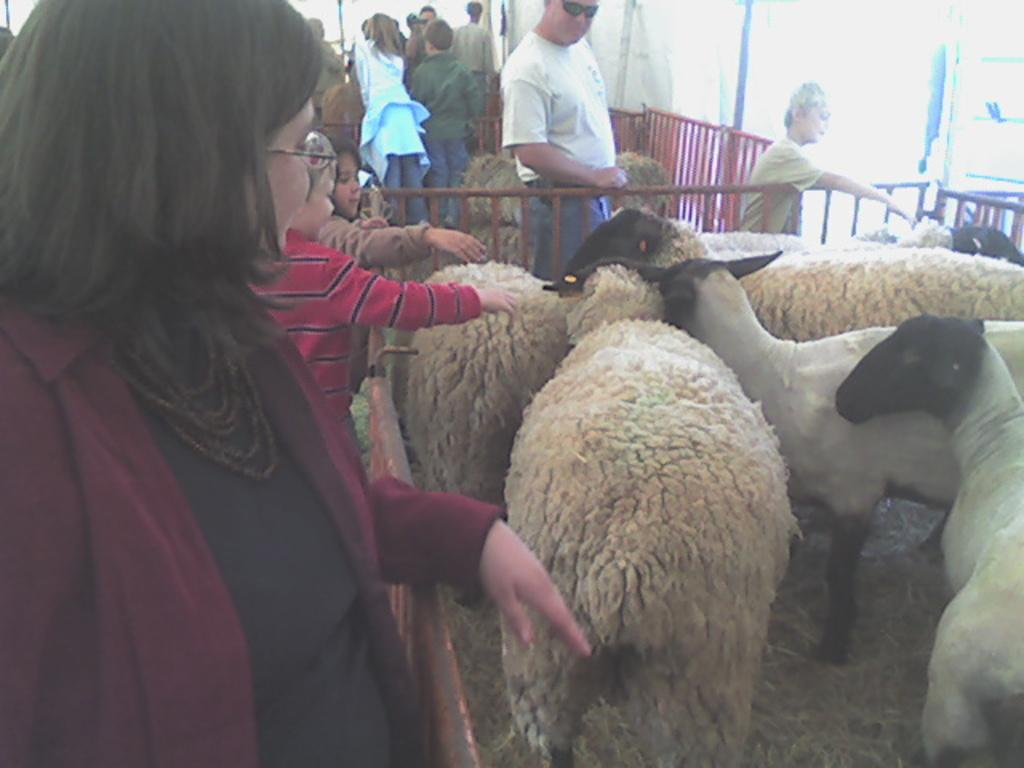What type of animals are present in the image? There are many sheep in the image. What is surrounding the sheep in the image? There are railings around the sheep. Are there any people visible in the image? Yes, there are people standing in the image. What can be seen on the ground in the image? Dried leaves are present on the ground in the image. What type of whip is being used to control the sheep in the image? There is no whip present in the image; the sheep are surrounded by railings. 